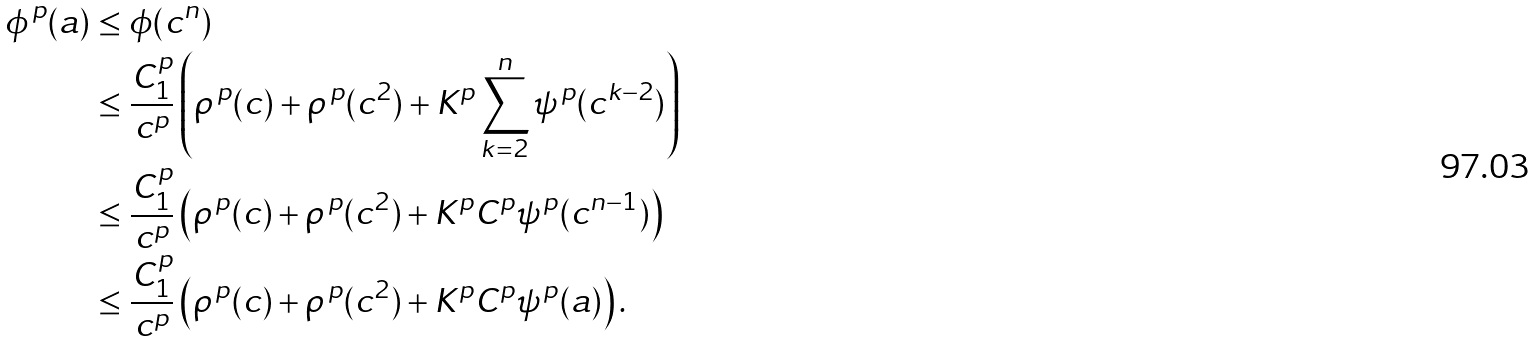<formula> <loc_0><loc_0><loc_500><loc_500>\phi ^ { \, p } ( a ) & \leq \phi ( c ^ { n } ) \\ & \leq \frac { C _ { 1 } ^ { p } } { c ^ { p } } \left ( \rho ^ { \, p } ( c ) + \rho ^ { \, p } ( c ^ { 2 } ) + K ^ { p } \sum _ { k = 2 } ^ { n } \psi ^ { \, p } ( c ^ { k - 2 } ) \right ) \\ & \leq \frac { C _ { 1 } ^ { p } } { c ^ { p } } \left ( \rho ^ { \, p } ( c ) + \rho ^ { \, p } ( c ^ { 2 } ) + K ^ { p } C ^ { p } \psi ^ { \, p } ( c ^ { n - 1 } ) \right ) \\ & \leq \frac { C _ { 1 } ^ { p } } { c ^ { p } } \left ( \rho ^ { \, p } ( c ) + \rho ^ { \, p } ( c ^ { 2 } ) + K ^ { p } C ^ { p } \psi ^ { \, p } ( a ) \right ) .</formula> 